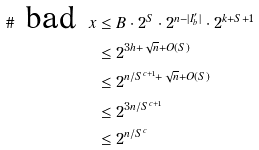Convert formula to latex. <formula><loc_0><loc_0><loc_500><loc_500>\# \text { bad } x & \leq B \cdot 2 ^ { S } \cdot 2 ^ { n - | I ^ { \prime } _ { b } | } \cdot 2 ^ { k + S + 1 } \\ & \leq 2 ^ { 3 h + \sqrt { n } + O ( S ) } \\ & \leq 2 ^ { n / S ^ { c + 1 } + \sqrt { n } + O ( S ) } \\ & \leq 2 ^ { 3 n / S ^ { c + 1 } } \\ & \leq 2 ^ { n / S ^ { c } }</formula> 